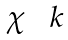Convert formula to latex. <formula><loc_0><loc_0><loc_500><loc_500>\begin{matrix} \chi & \ k \end{matrix}</formula> 